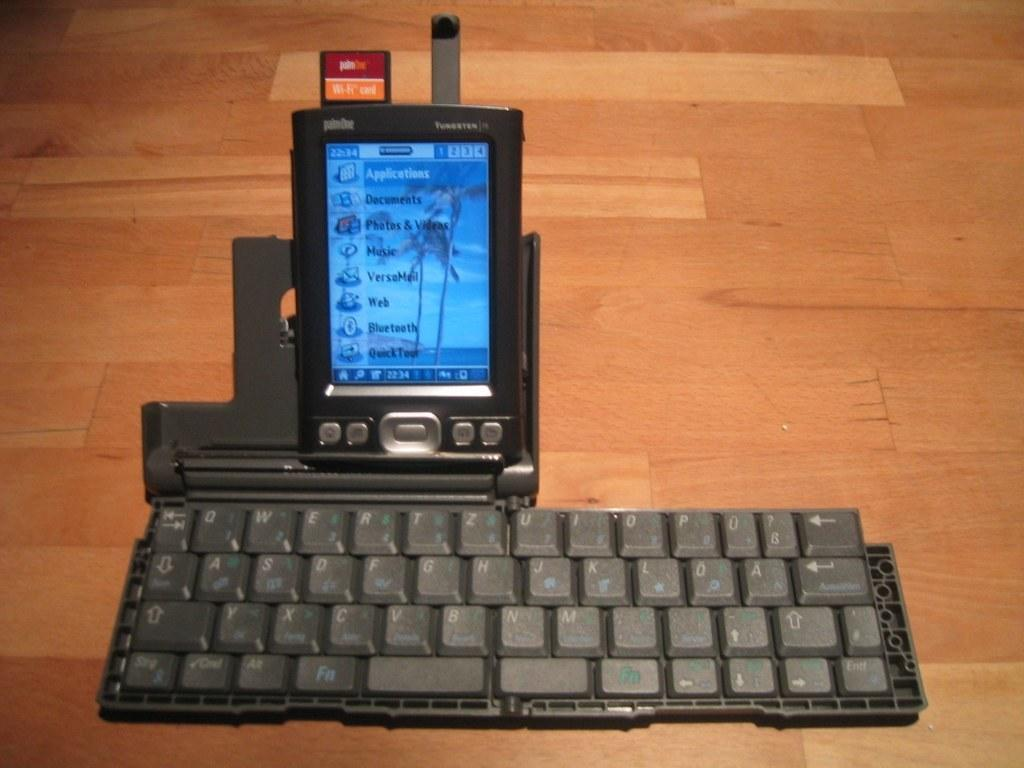<image>
Create a compact narrative representing the image presented. A hand-held device menu shows icons for documents and photos. 